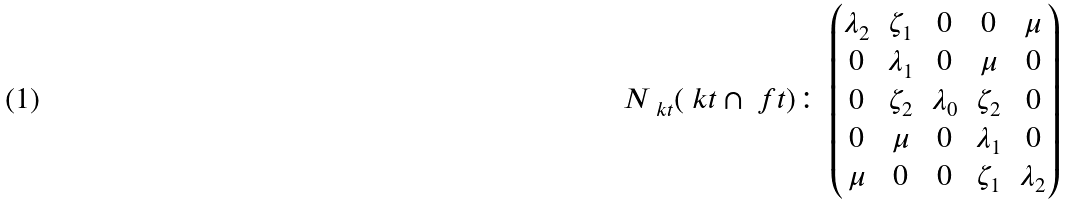<formula> <loc_0><loc_0><loc_500><loc_500>N _ { \ k t } ( { \ k t } \cap { \ f t } ) \colon \begin{pmatrix} \lambda _ { 2 } & \zeta _ { 1 } & 0 & 0 & \mu \\ 0 & \lambda _ { 1 } & 0 & \mu & 0 \\ 0 & \zeta _ { 2 } & \lambda _ { 0 } & \zeta _ { 2 } & 0 \\ 0 & \mu & 0 & \lambda _ { 1 } & 0 \\ \mu & 0 & 0 & \zeta _ { 1 } & \lambda _ { 2 } \end{pmatrix}</formula> 